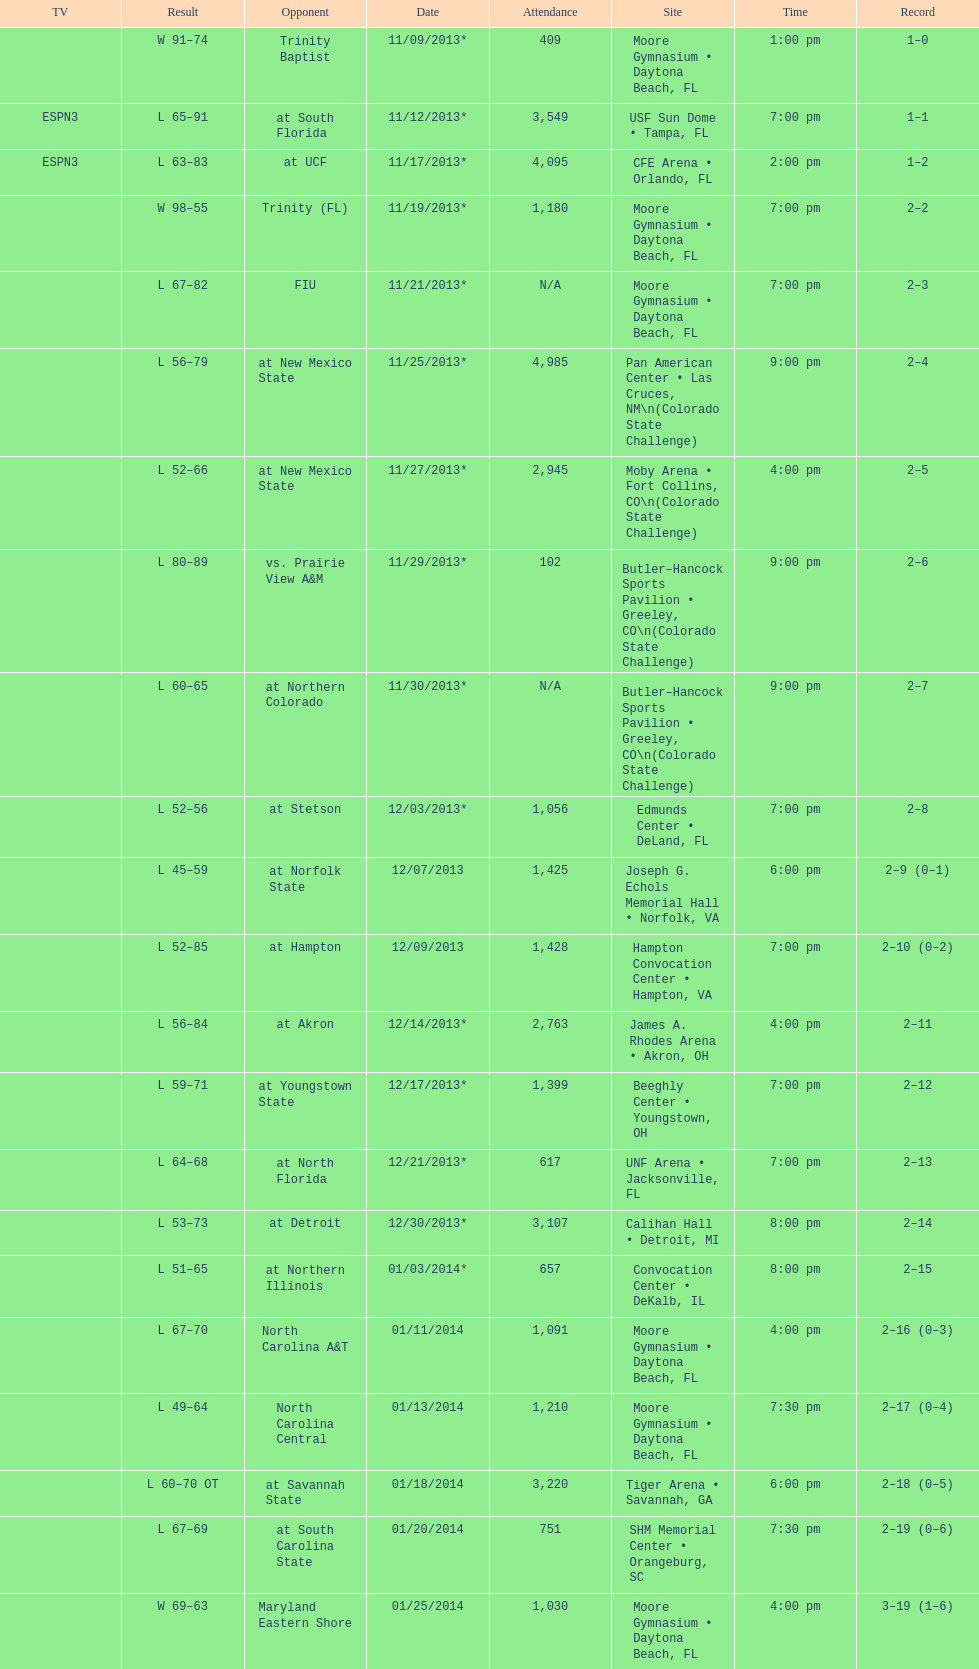Which game took place more into the night, fiu or northern colorado? Northern Colorado. 